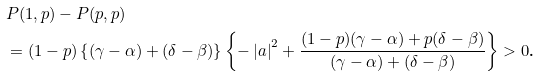Convert formula to latex. <formula><loc_0><loc_0><loc_500><loc_500>& P ( 1 , p ) - P ( p , p ) \\ & = ( 1 - p ) \left \{ ( \gamma - \alpha ) + ( \delta - \beta ) \right \} \left \{ - \left | a \right | ^ { 2 } + \frac { ( 1 - p ) ( \gamma - \alpha ) + p ( \delta - \beta ) } { ( \gamma - \alpha ) + ( \delta - \beta ) } \right \} > 0 \text {.} \\ &</formula> 